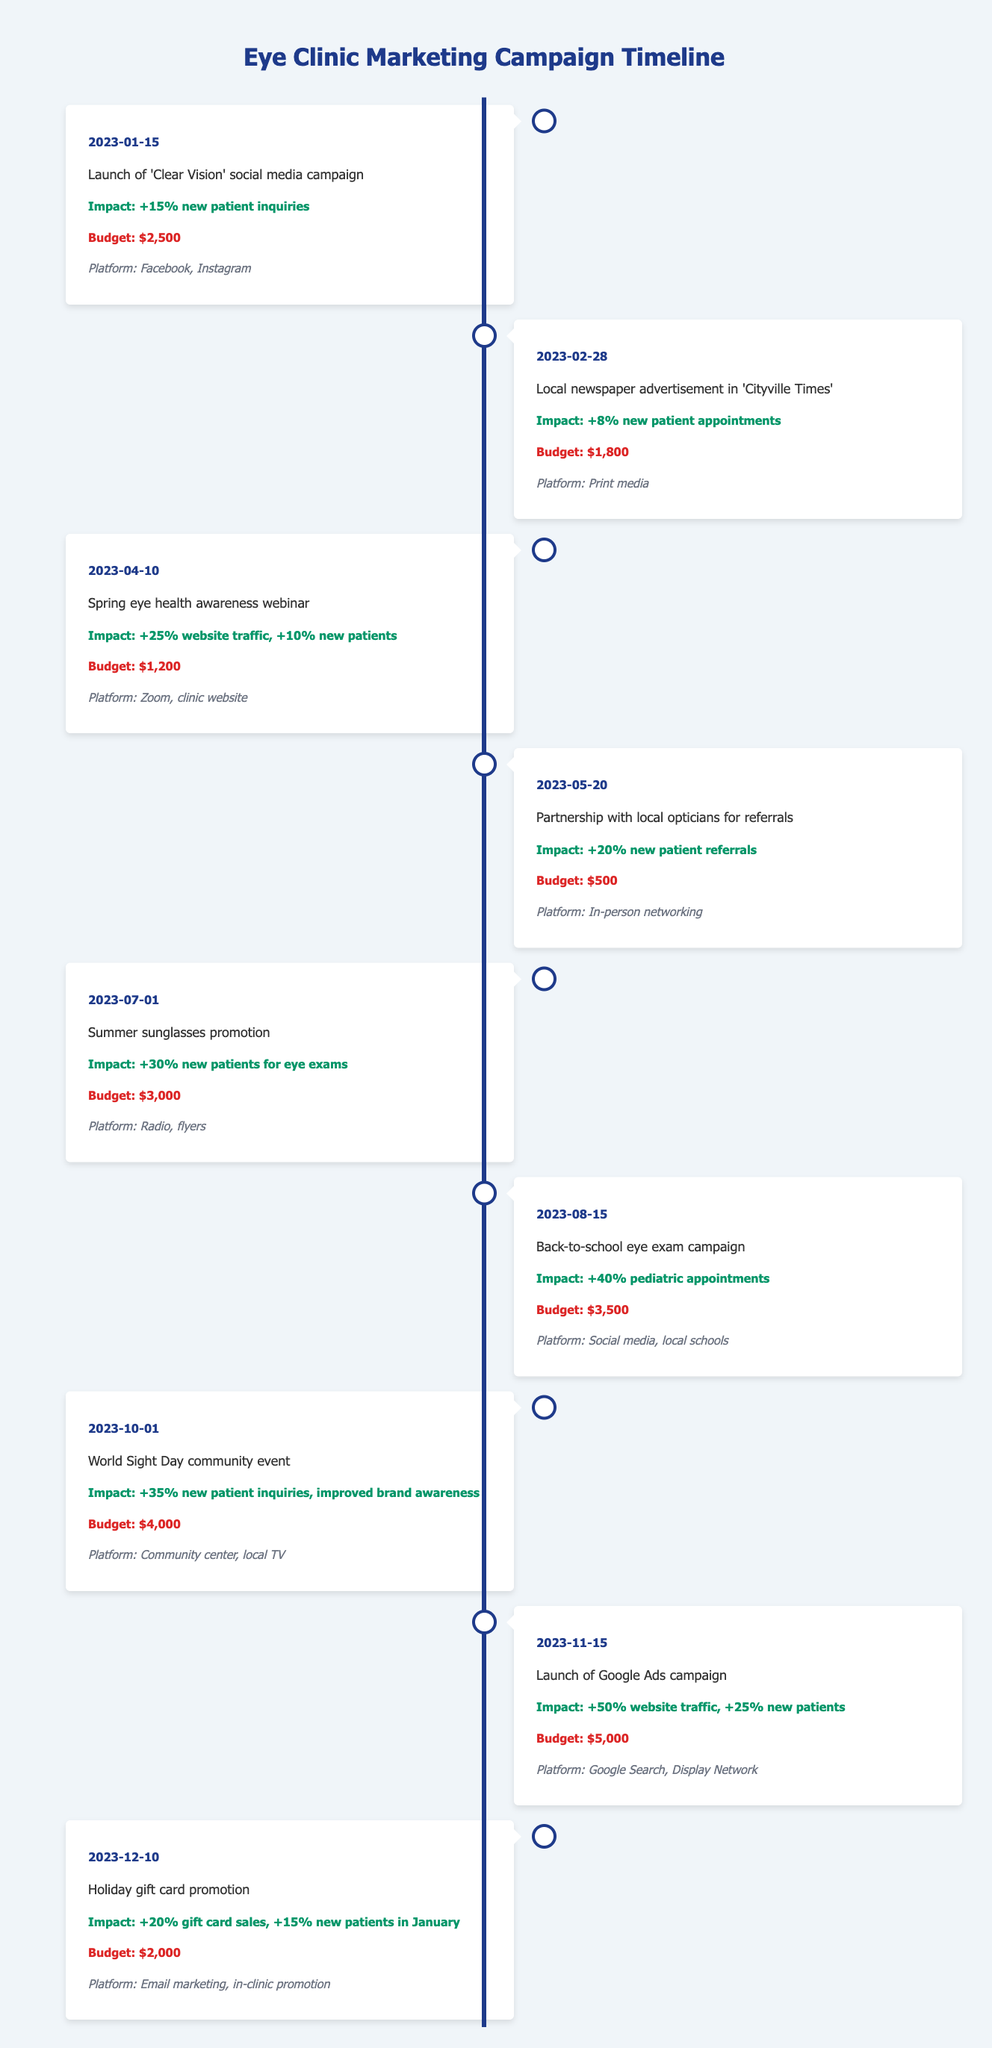What event had the highest impact on new patient inquiries? The highest impact on new patient inquiries was from the 'Launch of Google Ads campaign' on 2023-11-15, which resulted in a "+25% new patients". This is the only event that directly states a percentage increase related to inquiries.
Answer: +25% new patients What was the total budget for all campaigns in the first half of 2023? To find the total budget for the first half of 2023, add the budgets of each campaign from January to June. The budgets are $2,500 (January) + $1,800 (February) + $1,200 (April) + $500 (May) + $3,000 (July) = $9,000.
Answer: $9,000 Is there a campaign that specifically targeted pediatric patients? Yes, the 'Back-to-school eye exam campaign' on 2023-08-15 specifically targeted pediatric appointments with an impact of "+40% pediatric appointments".
Answer: Yes Which campaign had the least impact on new patient referrals? The campaign with the least impact on new patient referrals was the 'Partnership with local opticians for referrals' on 2023-05-20, which resulted in "+20% new patient referrals". It yields the lowest percentage increase in referrals compared to other campaigns.
Answer: +20% new patient referrals What is the average increase in new patient inquiries from the campaigns listed? To calculate the average increase in new patient inquiries, add the percentages of new patients from the relevant campaigns: +15% (January) + +8% (February) + +10% (April) + +20% (May) + +30% (July) + +40% (August) + +35% (October) + +25% (November) + +15% (December) = 15 + 8 + 10 + 20 + 30 + 40 + 35 + 25 + 15 = 188%. There are 9 campaigns, so the average is 188/9 = approximately 20.89%.
Answer: Approximately 20.89% How many campaigns resulted in an increase of more than 25% in new patients? Three campaigns resulted in an increase of more than 25% in new patients: the 'Summer sunglasses promotion' at +30%, the 'Back-to-school eye exam campaign' at +40%, and the 'Launch of Google Ads campaign' at +25%. Count these campaigns to get the total.
Answer: 3 